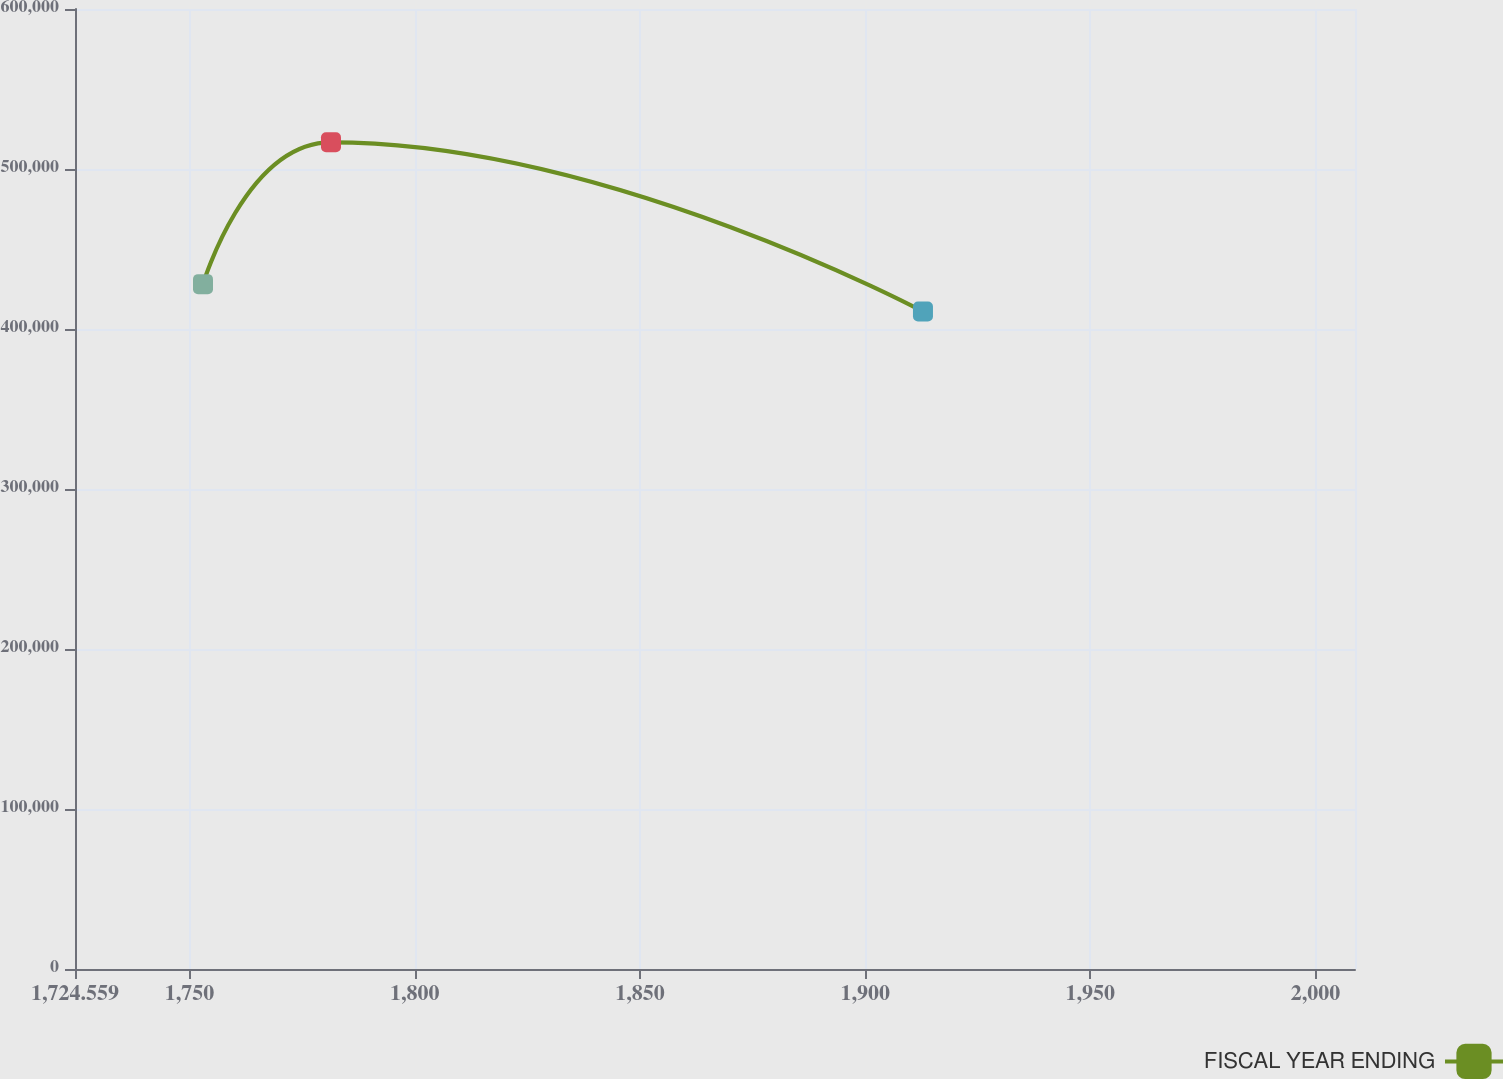Convert chart to OTSL. <chart><loc_0><loc_0><loc_500><loc_500><line_chart><ecel><fcel>FISCAL YEAR ENDING<nl><fcel>1752.98<fcel>428046<nl><fcel>1781.4<fcel>516673<nl><fcel>1912.84<fcel>410901<nl><fcel>2037.19<fcel>479078<nl></chart> 